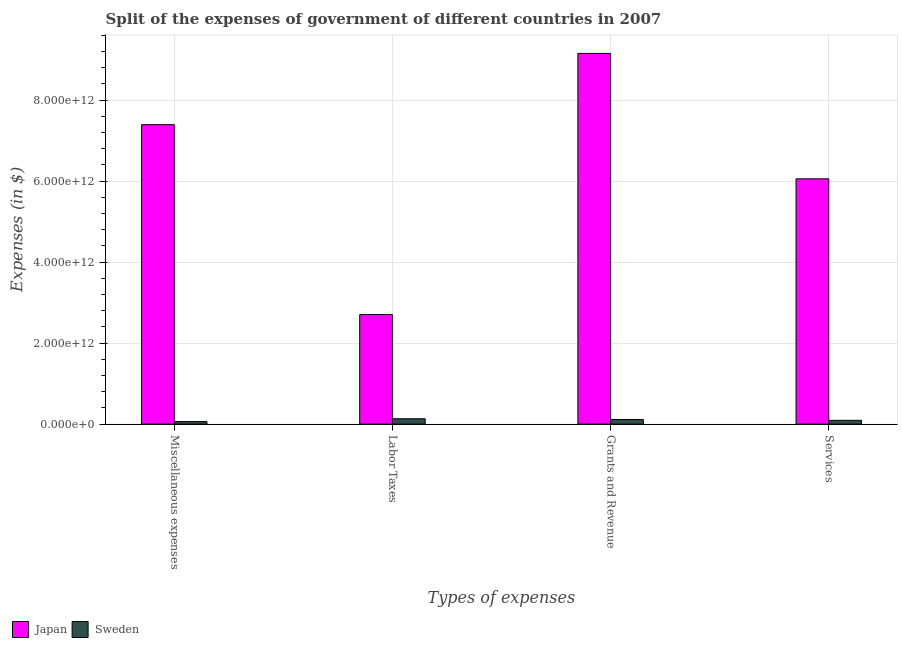How many different coloured bars are there?
Offer a terse response. 2. How many groups of bars are there?
Your response must be concise. 4. What is the label of the 4th group of bars from the left?
Provide a short and direct response. Services. What is the amount spent on services in Sweden?
Your answer should be compact. 9.34e+1. Across all countries, what is the maximum amount spent on miscellaneous expenses?
Give a very brief answer. 7.39e+12. Across all countries, what is the minimum amount spent on grants and revenue?
Provide a short and direct response. 1.15e+11. In which country was the amount spent on services minimum?
Offer a terse response. Sweden. What is the total amount spent on miscellaneous expenses in the graph?
Offer a very short reply. 7.46e+12. What is the difference between the amount spent on miscellaneous expenses in Sweden and that in Japan?
Ensure brevity in your answer.  -7.33e+12. What is the difference between the amount spent on grants and revenue in Sweden and the amount spent on services in Japan?
Your answer should be compact. -5.94e+12. What is the average amount spent on services per country?
Give a very brief answer. 3.07e+12. What is the difference between the amount spent on labor taxes and amount spent on services in Sweden?
Your answer should be very brief. 3.93e+1. In how many countries, is the amount spent on miscellaneous expenses greater than 4800000000000 $?
Give a very brief answer. 1. What is the ratio of the amount spent on services in Japan to that in Sweden?
Keep it short and to the point. 64.86. Is the difference between the amount spent on miscellaneous expenses in Japan and Sweden greater than the difference between the amount spent on services in Japan and Sweden?
Make the answer very short. Yes. What is the difference between the highest and the second highest amount spent on grants and revenue?
Offer a terse response. 9.04e+12. What is the difference between the highest and the lowest amount spent on services?
Offer a terse response. 5.96e+12. Is the sum of the amount spent on grants and revenue in Sweden and Japan greater than the maximum amount spent on services across all countries?
Provide a short and direct response. Yes. Is it the case that in every country, the sum of the amount spent on services and amount spent on grants and revenue is greater than the sum of amount spent on labor taxes and amount spent on miscellaneous expenses?
Ensure brevity in your answer.  No. What does the 1st bar from the left in Services represents?
Make the answer very short. Japan. How many bars are there?
Your response must be concise. 8. How many countries are there in the graph?
Ensure brevity in your answer.  2. What is the difference between two consecutive major ticks on the Y-axis?
Give a very brief answer. 2.00e+12. Are the values on the major ticks of Y-axis written in scientific E-notation?
Ensure brevity in your answer.  Yes. Does the graph contain any zero values?
Your response must be concise. No. How many legend labels are there?
Provide a succinct answer. 2. How are the legend labels stacked?
Your answer should be very brief. Horizontal. What is the title of the graph?
Provide a short and direct response. Split of the expenses of government of different countries in 2007. Does "United Kingdom" appear as one of the legend labels in the graph?
Your answer should be compact. No. What is the label or title of the X-axis?
Provide a succinct answer. Types of expenses. What is the label or title of the Y-axis?
Keep it short and to the point. Expenses (in $). What is the Expenses (in $) of Japan in Miscellaneous expenses?
Provide a short and direct response. 7.39e+12. What is the Expenses (in $) of Sweden in Miscellaneous expenses?
Your response must be concise. 6.32e+1. What is the Expenses (in $) in Japan in Labor Taxes?
Your answer should be compact. 2.70e+12. What is the Expenses (in $) of Sweden in Labor Taxes?
Your answer should be very brief. 1.33e+11. What is the Expenses (in $) of Japan in Grants and Revenue?
Provide a succinct answer. 9.15e+12. What is the Expenses (in $) of Sweden in Grants and Revenue?
Give a very brief answer. 1.15e+11. What is the Expenses (in $) of Japan in Services?
Provide a short and direct response. 6.06e+12. What is the Expenses (in $) of Sweden in Services?
Your answer should be very brief. 9.34e+1. Across all Types of expenses, what is the maximum Expenses (in $) in Japan?
Keep it short and to the point. 9.15e+12. Across all Types of expenses, what is the maximum Expenses (in $) of Sweden?
Your answer should be very brief. 1.33e+11. Across all Types of expenses, what is the minimum Expenses (in $) in Japan?
Ensure brevity in your answer.  2.70e+12. Across all Types of expenses, what is the minimum Expenses (in $) in Sweden?
Make the answer very short. 6.32e+1. What is the total Expenses (in $) in Japan in the graph?
Your answer should be compact. 2.53e+13. What is the total Expenses (in $) of Sweden in the graph?
Your answer should be very brief. 4.04e+11. What is the difference between the Expenses (in $) of Japan in Miscellaneous expenses and that in Labor Taxes?
Offer a terse response. 4.69e+12. What is the difference between the Expenses (in $) in Sweden in Miscellaneous expenses and that in Labor Taxes?
Keep it short and to the point. -6.95e+1. What is the difference between the Expenses (in $) of Japan in Miscellaneous expenses and that in Grants and Revenue?
Give a very brief answer. -1.76e+12. What is the difference between the Expenses (in $) in Sweden in Miscellaneous expenses and that in Grants and Revenue?
Give a very brief answer. -5.14e+1. What is the difference between the Expenses (in $) of Japan in Miscellaneous expenses and that in Services?
Your response must be concise. 1.34e+12. What is the difference between the Expenses (in $) in Sweden in Miscellaneous expenses and that in Services?
Your answer should be compact. -3.02e+1. What is the difference between the Expenses (in $) in Japan in Labor Taxes and that in Grants and Revenue?
Your answer should be compact. -6.45e+12. What is the difference between the Expenses (in $) of Sweden in Labor Taxes and that in Grants and Revenue?
Offer a very short reply. 1.81e+1. What is the difference between the Expenses (in $) of Japan in Labor Taxes and that in Services?
Offer a very short reply. -3.35e+12. What is the difference between the Expenses (in $) in Sweden in Labor Taxes and that in Services?
Ensure brevity in your answer.  3.93e+1. What is the difference between the Expenses (in $) of Japan in Grants and Revenue and that in Services?
Keep it short and to the point. 3.10e+12. What is the difference between the Expenses (in $) in Sweden in Grants and Revenue and that in Services?
Keep it short and to the point. 2.13e+1. What is the difference between the Expenses (in $) in Japan in Miscellaneous expenses and the Expenses (in $) in Sweden in Labor Taxes?
Give a very brief answer. 7.26e+12. What is the difference between the Expenses (in $) of Japan in Miscellaneous expenses and the Expenses (in $) of Sweden in Grants and Revenue?
Your response must be concise. 7.28e+12. What is the difference between the Expenses (in $) in Japan in Miscellaneous expenses and the Expenses (in $) in Sweden in Services?
Your answer should be compact. 7.30e+12. What is the difference between the Expenses (in $) in Japan in Labor Taxes and the Expenses (in $) in Sweden in Grants and Revenue?
Keep it short and to the point. 2.59e+12. What is the difference between the Expenses (in $) of Japan in Labor Taxes and the Expenses (in $) of Sweden in Services?
Offer a terse response. 2.61e+12. What is the difference between the Expenses (in $) in Japan in Grants and Revenue and the Expenses (in $) in Sweden in Services?
Ensure brevity in your answer.  9.06e+12. What is the average Expenses (in $) in Japan per Types of expenses?
Make the answer very short. 6.33e+12. What is the average Expenses (in $) of Sweden per Types of expenses?
Provide a succinct answer. 1.01e+11. What is the difference between the Expenses (in $) in Japan and Expenses (in $) in Sweden in Miscellaneous expenses?
Your answer should be very brief. 7.33e+12. What is the difference between the Expenses (in $) in Japan and Expenses (in $) in Sweden in Labor Taxes?
Make the answer very short. 2.57e+12. What is the difference between the Expenses (in $) of Japan and Expenses (in $) of Sweden in Grants and Revenue?
Make the answer very short. 9.04e+12. What is the difference between the Expenses (in $) of Japan and Expenses (in $) of Sweden in Services?
Ensure brevity in your answer.  5.96e+12. What is the ratio of the Expenses (in $) of Japan in Miscellaneous expenses to that in Labor Taxes?
Offer a very short reply. 2.73. What is the ratio of the Expenses (in $) of Sweden in Miscellaneous expenses to that in Labor Taxes?
Offer a very short reply. 0.48. What is the ratio of the Expenses (in $) of Japan in Miscellaneous expenses to that in Grants and Revenue?
Ensure brevity in your answer.  0.81. What is the ratio of the Expenses (in $) of Sweden in Miscellaneous expenses to that in Grants and Revenue?
Your answer should be compact. 0.55. What is the ratio of the Expenses (in $) in Japan in Miscellaneous expenses to that in Services?
Offer a very short reply. 1.22. What is the ratio of the Expenses (in $) in Sweden in Miscellaneous expenses to that in Services?
Make the answer very short. 0.68. What is the ratio of the Expenses (in $) in Japan in Labor Taxes to that in Grants and Revenue?
Your response must be concise. 0.3. What is the ratio of the Expenses (in $) of Sweden in Labor Taxes to that in Grants and Revenue?
Provide a short and direct response. 1.16. What is the ratio of the Expenses (in $) of Japan in Labor Taxes to that in Services?
Your answer should be very brief. 0.45. What is the ratio of the Expenses (in $) in Sweden in Labor Taxes to that in Services?
Your response must be concise. 1.42. What is the ratio of the Expenses (in $) of Japan in Grants and Revenue to that in Services?
Provide a succinct answer. 1.51. What is the ratio of the Expenses (in $) in Sweden in Grants and Revenue to that in Services?
Give a very brief answer. 1.23. What is the difference between the highest and the second highest Expenses (in $) in Japan?
Your answer should be very brief. 1.76e+12. What is the difference between the highest and the second highest Expenses (in $) of Sweden?
Give a very brief answer. 1.81e+1. What is the difference between the highest and the lowest Expenses (in $) of Japan?
Give a very brief answer. 6.45e+12. What is the difference between the highest and the lowest Expenses (in $) of Sweden?
Make the answer very short. 6.95e+1. 